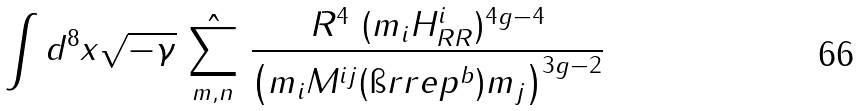Convert formula to latex. <formula><loc_0><loc_0><loc_500><loc_500>\int d ^ { 8 } x \sqrt { - \gamma } \ \hat { \sum _ { m , n } } \ \frac { R ^ { 4 } \ ( m _ { i } H _ { R R } ^ { i } ) ^ { 4 g - 4 } } { \left ( m _ { i } { M } ^ { i j } ( \i r r e p { ^ { b } } ) m _ { j } \right ) ^ { 3 g - 2 } }</formula> 